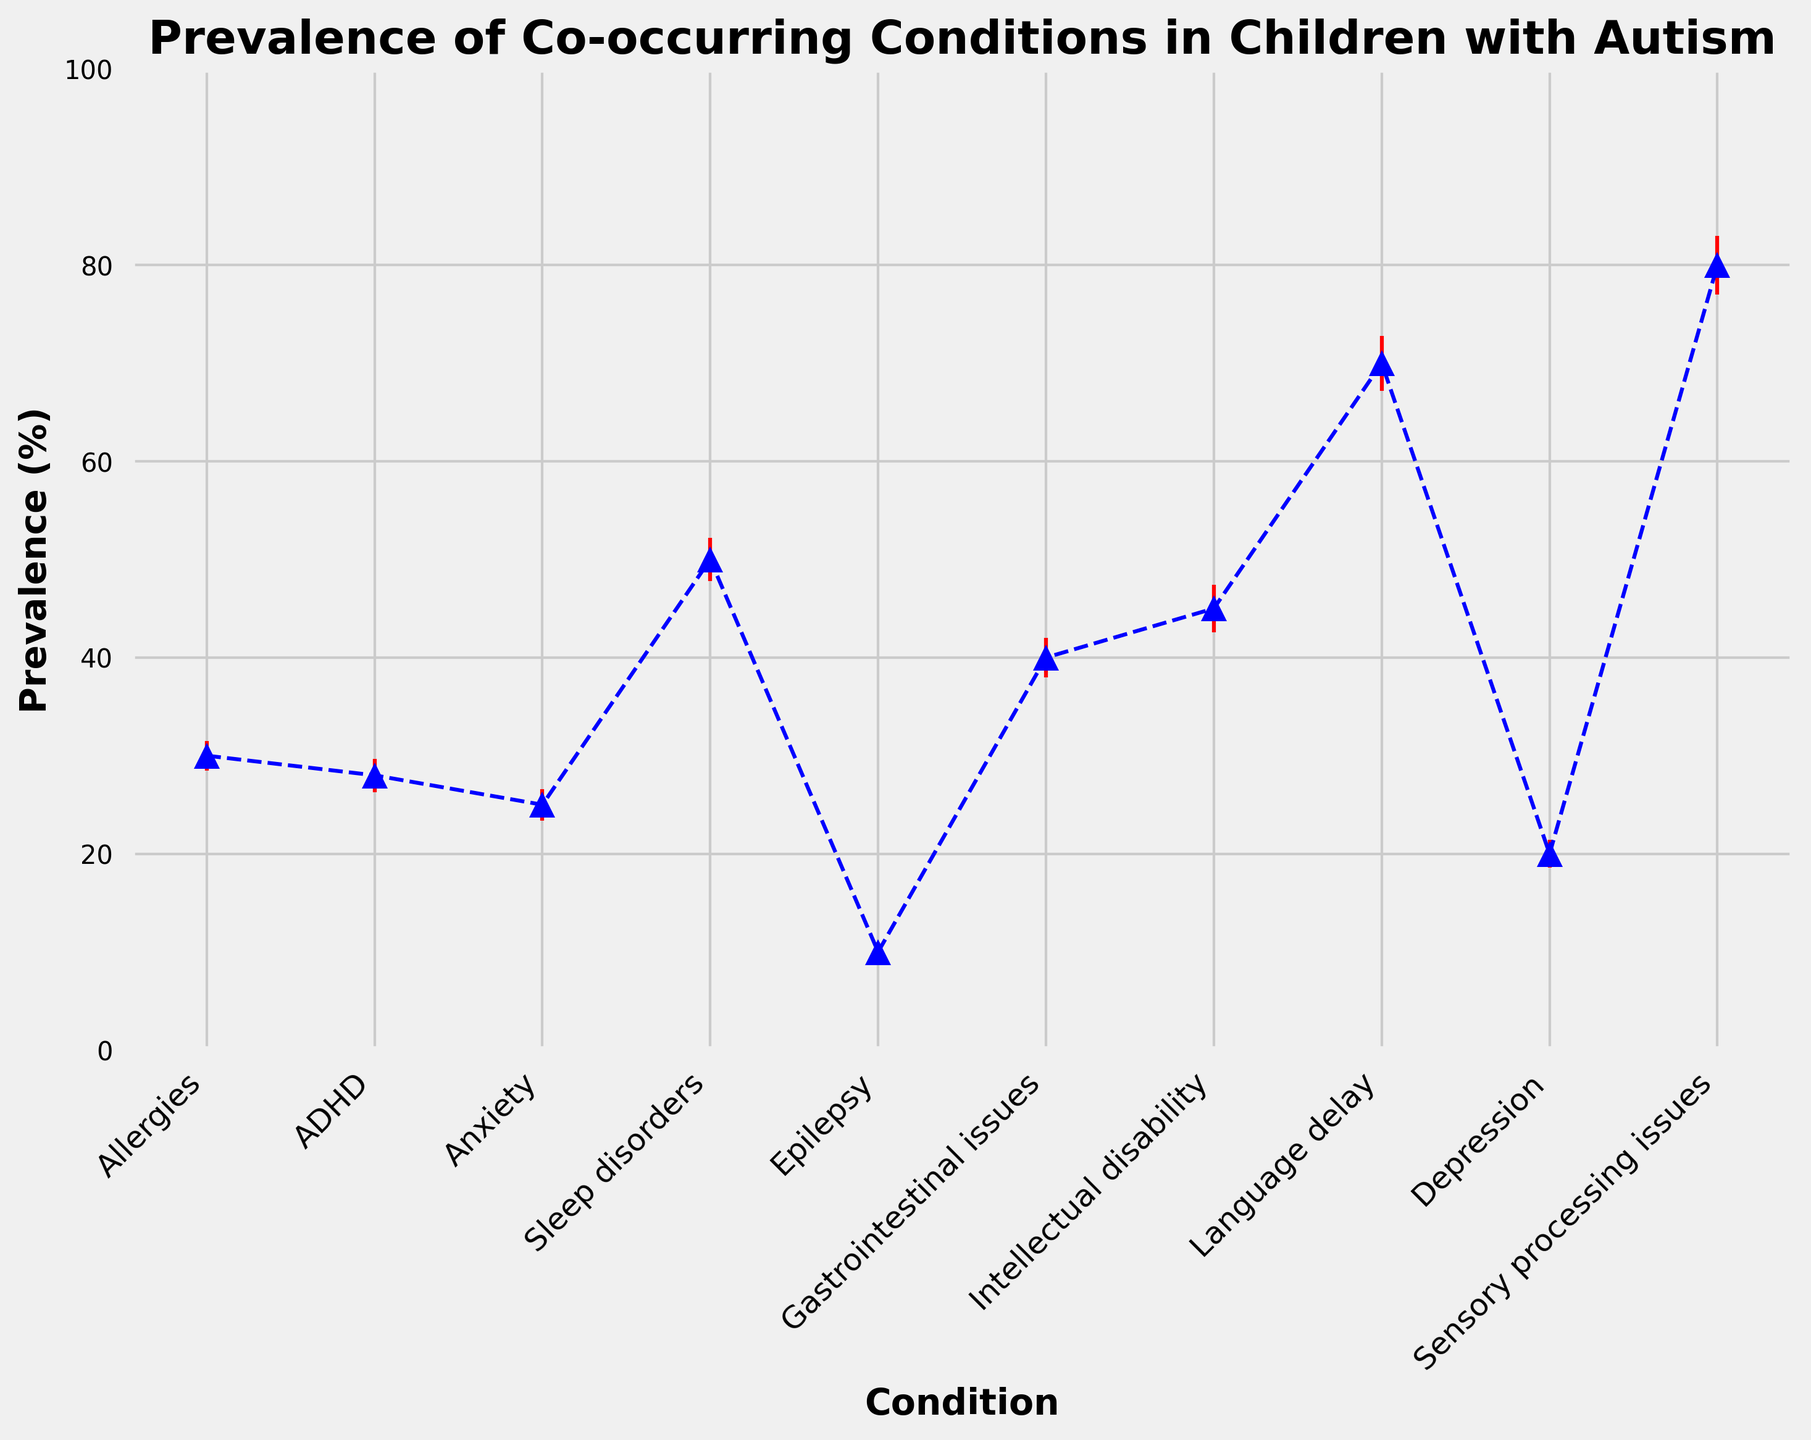What condition has the highest prevalence in children with autism? By observing the plot, we see that 'Sensory processing issues' has the highest prevalence as it reaches 80%.
Answer: Sensory processing issues Which two conditions have a prevalence greater than 60%? From the chart, 'Language delay' and 'Sensory processing issues' have prevalence values of 70% and 80%, respectively, which are both above 60%.
Answer: Language delay and Sensory processing issues Which condition has the lowest standard error? Referring to the error bars, 'Epilepsy' has the smallest error bar, indicating the lowest standard error of 1.0%.
Answer: Epilepsy How much higher is the prevalence of 'Sleep disorders' compared to 'Depression'? 'Sleep disorders' has a prevalence of 50%, and 'Depression' has 20%. The difference is calculated as 50% - 20% = 30%.
Answer: 30% What is the average prevalence of 'Allergies' and 'ADHD'? The prevalence values for 'Allergies' and 'ADHD' are 30% and 28%, respectively. The average is calculated as (30% + 28%) / 2 = 29%.
Answer: 29% Are there more conditions with a prevalence above 40% or below 40%? Conditions above 40%: 'Sleep disorders', 'Gastrointestinal issues', 'Intellectual disability', 'Language delay', 'Sensory processing issues' (5 conditions). Below 40%: 'Allergies', 'ADHD', 'Anxiety', 'Epilepsy', 'Depression' (5 conditions). Both are equal in number.
Answer: Equal Which condition has the highest standard error, and what is its value? By observing the error bars, 'Sensory processing issues' has the highest standard error, visually it's noticeably larger, which confirms that it is 3.0%.
Answer: Sensory processing issues, 3.0% Is the prevalence of 'Gastrointestinal issues' more than double that of 'Epilepsy'? 'Gastrointestinal issues' has a prevalence of 40%, while 'Epilepsy' has 10%. Since 40% is more than double 10%, the answer is yes.
Answer: Yes Which three conditions have prevalences that combine to approximately 100%? 'Allergies' (30%), 'ADHD' (28%), and 'Anxiety' (25%) add up to approximately 30% + 28% + 25% = 83%, closer to 100% when considering errors. Similarly, the next close sum is including 'Intellectual disability' (45%), 'Language delay' (70%), not exactly meeting the 100%. This pair combination should be exhaustively evaluated further.
Answer: Allergies, ADHD, Anxiety 